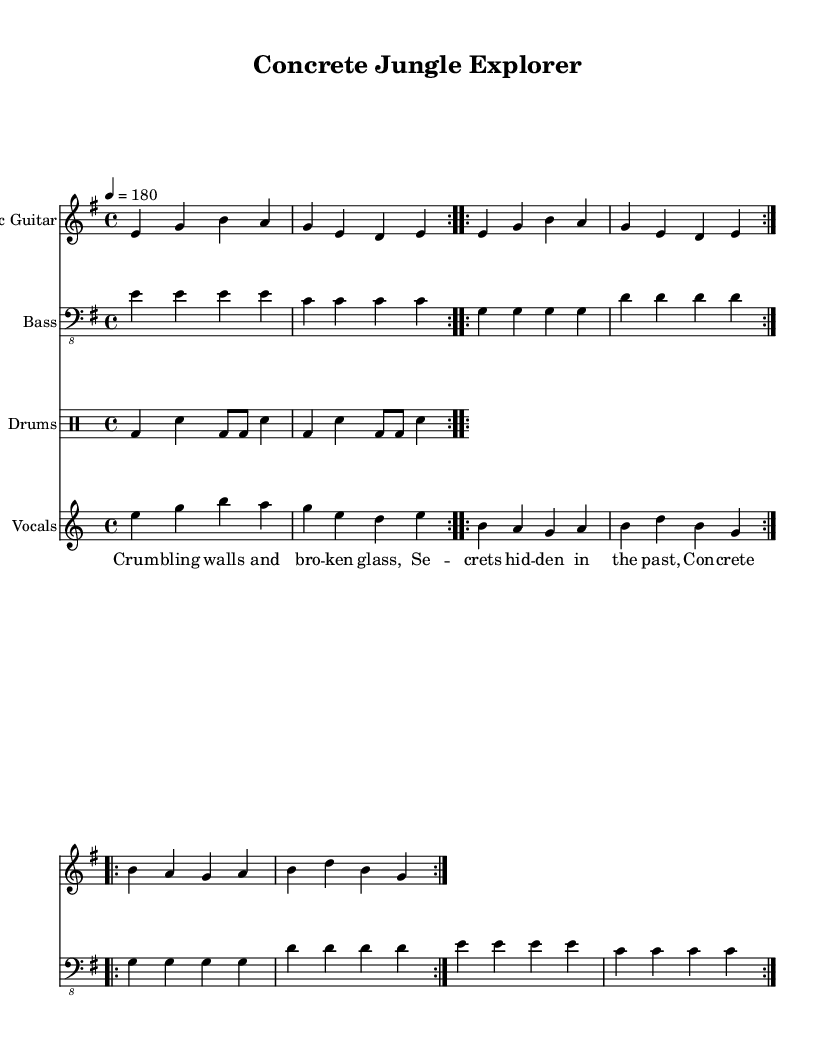What is the key signature of this music? The key signature is E minor, which has one sharp (F#).
Answer: E minor What is the time signature of this music? The time signature is 4/4, indicating four beats per measure.
Answer: 4/4 What is the tempo marking for this piece? The tempo is marked as quarter note equals 180 BPM, indicating a fast pace typical of punk rock.
Answer: 180 How many times does the main guitar riff repeat? The main guitar riff is marked to repeat four times based on the volta signs.
Answer: Four times What is the central theme of the lyrics? The lyrics focus on urban exploration, particularly in abandoned places, which reflects the punk subculture's interest in defiance and discovery.
Answer: Urban exploration What instrument plays the main melody in this piece? The main melody is played by the Electric Guitar, which is the first staff notated in the music.
Answer: Electric Guitar What type of rhythmic pattern is primarily used in the drums? The drums feature a mix of bass drum hits and snare, defined by the specified drummode notation.
Answer: Bass and snare 